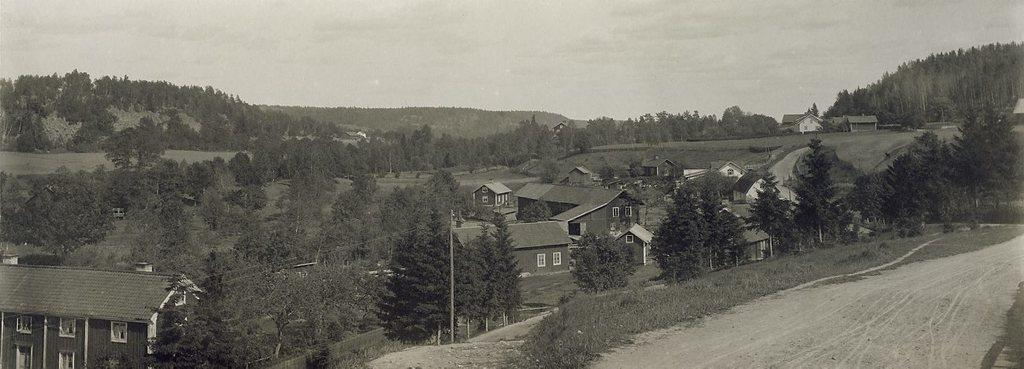What type of surface can be seen in the image? There is a road in the image. What type of vegetation is present in the image? There is grass on the ground and trees in the image. What type of structures are visible in the image? There are poles and buildings in the image. What can be seen in the background of the image? There are mountains, additional trees, additional buildings, and the sky visible in the background of the image. Who is the owner of the salt in the image? There is no salt present in the image. What is the reason for the mountains being in the image? The mountains are a natural part of the landscape and do not have a specific reason for being in the image. 